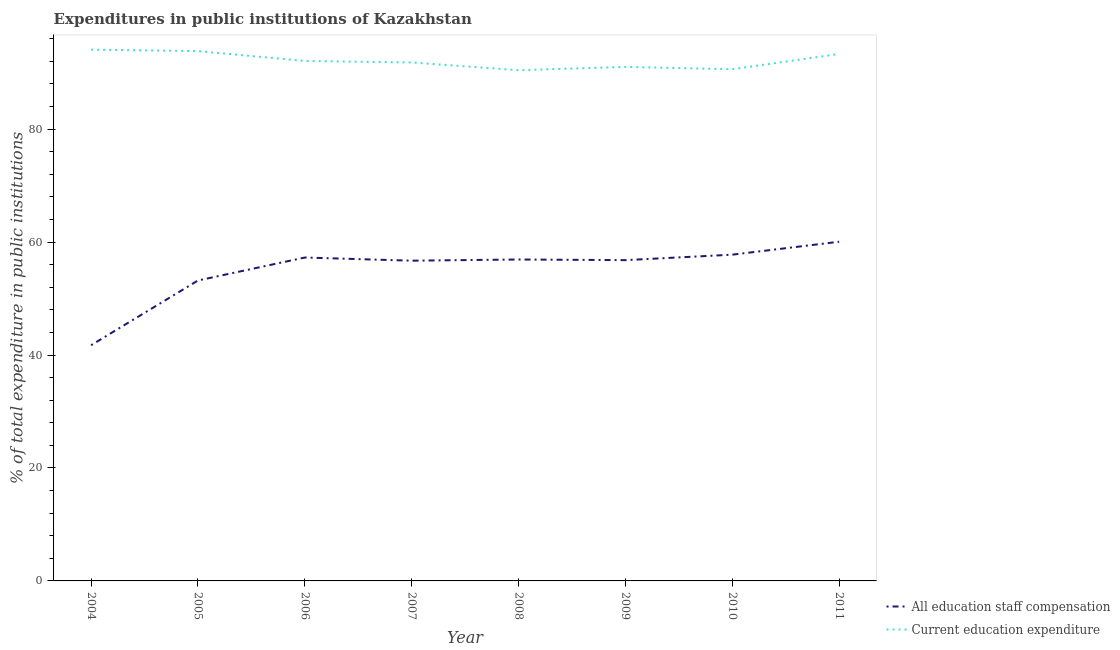Does the line corresponding to expenditure in staff compensation intersect with the line corresponding to expenditure in education?
Offer a terse response. No. What is the expenditure in staff compensation in 2004?
Your answer should be compact. 41.74. Across all years, what is the maximum expenditure in staff compensation?
Provide a short and direct response. 60.06. Across all years, what is the minimum expenditure in education?
Give a very brief answer. 90.43. In which year was the expenditure in education maximum?
Keep it short and to the point. 2004. What is the total expenditure in staff compensation in the graph?
Keep it short and to the point. 440.46. What is the difference between the expenditure in staff compensation in 2006 and that in 2010?
Your response must be concise. -0.5. What is the difference between the expenditure in education in 2004 and the expenditure in staff compensation in 2008?
Provide a succinct answer. 37.16. What is the average expenditure in staff compensation per year?
Make the answer very short. 55.06. In the year 2011, what is the difference between the expenditure in education and expenditure in staff compensation?
Provide a short and direct response. 33.25. In how many years, is the expenditure in staff compensation greater than 40 %?
Your response must be concise. 8. What is the ratio of the expenditure in staff compensation in 2005 to that in 2008?
Ensure brevity in your answer.  0.93. Is the difference between the expenditure in staff compensation in 2008 and 2011 greater than the difference between the expenditure in education in 2008 and 2011?
Offer a terse response. No. What is the difference between the highest and the second highest expenditure in education?
Provide a short and direct response. 0.26. What is the difference between the highest and the lowest expenditure in education?
Make the answer very short. 3.64. Is the sum of the expenditure in staff compensation in 2005 and 2006 greater than the maximum expenditure in education across all years?
Provide a succinct answer. Yes. Does the expenditure in staff compensation monotonically increase over the years?
Offer a very short reply. No. Is the expenditure in staff compensation strictly greater than the expenditure in education over the years?
Provide a succinct answer. No. Is the expenditure in education strictly less than the expenditure in staff compensation over the years?
Keep it short and to the point. No. How many lines are there?
Your response must be concise. 2. How many years are there in the graph?
Provide a short and direct response. 8. What is the difference between two consecutive major ticks on the Y-axis?
Your answer should be very brief. 20. Does the graph contain any zero values?
Your answer should be very brief. No. Where does the legend appear in the graph?
Give a very brief answer. Bottom right. How are the legend labels stacked?
Offer a terse response. Vertical. What is the title of the graph?
Provide a short and direct response. Expenditures in public institutions of Kazakhstan. What is the label or title of the Y-axis?
Make the answer very short. % of total expenditure in public institutions. What is the % of total expenditure in public institutions in All education staff compensation in 2004?
Your answer should be compact. 41.74. What is the % of total expenditure in public institutions in Current education expenditure in 2004?
Give a very brief answer. 94.07. What is the % of total expenditure in public institutions of All education staff compensation in 2005?
Your answer should be compact. 53.2. What is the % of total expenditure in public institutions in Current education expenditure in 2005?
Give a very brief answer. 93.81. What is the % of total expenditure in public institutions in All education staff compensation in 2006?
Offer a terse response. 57.27. What is the % of total expenditure in public institutions of Current education expenditure in 2006?
Ensure brevity in your answer.  92.07. What is the % of total expenditure in public institutions of All education staff compensation in 2007?
Ensure brevity in your answer.  56.71. What is the % of total expenditure in public institutions of Current education expenditure in 2007?
Your answer should be compact. 91.8. What is the % of total expenditure in public institutions in All education staff compensation in 2008?
Ensure brevity in your answer.  56.92. What is the % of total expenditure in public institutions of Current education expenditure in 2008?
Offer a terse response. 90.43. What is the % of total expenditure in public institutions in All education staff compensation in 2009?
Your answer should be very brief. 56.8. What is the % of total expenditure in public institutions of Current education expenditure in 2009?
Give a very brief answer. 91.02. What is the % of total expenditure in public institutions of All education staff compensation in 2010?
Your answer should be very brief. 57.77. What is the % of total expenditure in public institutions in Current education expenditure in 2010?
Offer a very short reply. 90.6. What is the % of total expenditure in public institutions of All education staff compensation in 2011?
Make the answer very short. 60.06. What is the % of total expenditure in public institutions in Current education expenditure in 2011?
Make the answer very short. 93.31. Across all years, what is the maximum % of total expenditure in public institutions in All education staff compensation?
Your response must be concise. 60.06. Across all years, what is the maximum % of total expenditure in public institutions of Current education expenditure?
Your response must be concise. 94.07. Across all years, what is the minimum % of total expenditure in public institutions in All education staff compensation?
Your response must be concise. 41.74. Across all years, what is the minimum % of total expenditure in public institutions of Current education expenditure?
Offer a terse response. 90.43. What is the total % of total expenditure in public institutions in All education staff compensation in the graph?
Your response must be concise. 440.46. What is the total % of total expenditure in public institutions of Current education expenditure in the graph?
Provide a short and direct response. 737.13. What is the difference between the % of total expenditure in public institutions of All education staff compensation in 2004 and that in 2005?
Your answer should be compact. -11.46. What is the difference between the % of total expenditure in public institutions in Current education expenditure in 2004 and that in 2005?
Provide a succinct answer. 0.26. What is the difference between the % of total expenditure in public institutions in All education staff compensation in 2004 and that in 2006?
Offer a very short reply. -15.53. What is the difference between the % of total expenditure in public institutions of Current education expenditure in 2004 and that in 2006?
Your response must be concise. 2. What is the difference between the % of total expenditure in public institutions in All education staff compensation in 2004 and that in 2007?
Provide a succinct answer. -14.97. What is the difference between the % of total expenditure in public institutions of Current education expenditure in 2004 and that in 2007?
Ensure brevity in your answer.  2.27. What is the difference between the % of total expenditure in public institutions in All education staff compensation in 2004 and that in 2008?
Give a very brief answer. -15.18. What is the difference between the % of total expenditure in public institutions in Current education expenditure in 2004 and that in 2008?
Ensure brevity in your answer.  3.64. What is the difference between the % of total expenditure in public institutions of All education staff compensation in 2004 and that in 2009?
Provide a succinct answer. -15.06. What is the difference between the % of total expenditure in public institutions of Current education expenditure in 2004 and that in 2009?
Your response must be concise. 3.05. What is the difference between the % of total expenditure in public institutions in All education staff compensation in 2004 and that in 2010?
Provide a short and direct response. -16.03. What is the difference between the % of total expenditure in public institutions of Current education expenditure in 2004 and that in 2010?
Make the answer very short. 3.47. What is the difference between the % of total expenditure in public institutions in All education staff compensation in 2004 and that in 2011?
Keep it short and to the point. -18.32. What is the difference between the % of total expenditure in public institutions in Current education expenditure in 2004 and that in 2011?
Offer a very short reply. 0.76. What is the difference between the % of total expenditure in public institutions of All education staff compensation in 2005 and that in 2006?
Offer a very short reply. -4.07. What is the difference between the % of total expenditure in public institutions of Current education expenditure in 2005 and that in 2006?
Keep it short and to the point. 1.74. What is the difference between the % of total expenditure in public institutions of All education staff compensation in 2005 and that in 2007?
Your answer should be very brief. -3.51. What is the difference between the % of total expenditure in public institutions in Current education expenditure in 2005 and that in 2007?
Your answer should be very brief. 2.01. What is the difference between the % of total expenditure in public institutions of All education staff compensation in 2005 and that in 2008?
Give a very brief answer. -3.72. What is the difference between the % of total expenditure in public institutions in Current education expenditure in 2005 and that in 2008?
Your answer should be very brief. 3.38. What is the difference between the % of total expenditure in public institutions in All education staff compensation in 2005 and that in 2009?
Your answer should be compact. -3.6. What is the difference between the % of total expenditure in public institutions of Current education expenditure in 2005 and that in 2009?
Provide a succinct answer. 2.79. What is the difference between the % of total expenditure in public institutions of All education staff compensation in 2005 and that in 2010?
Make the answer very short. -4.57. What is the difference between the % of total expenditure in public institutions in Current education expenditure in 2005 and that in 2010?
Make the answer very short. 3.21. What is the difference between the % of total expenditure in public institutions of All education staff compensation in 2005 and that in 2011?
Your answer should be compact. -6.86. What is the difference between the % of total expenditure in public institutions in Current education expenditure in 2005 and that in 2011?
Provide a succinct answer. 0.5. What is the difference between the % of total expenditure in public institutions of All education staff compensation in 2006 and that in 2007?
Give a very brief answer. 0.56. What is the difference between the % of total expenditure in public institutions in Current education expenditure in 2006 and that in 2007?
Make the answer very short. 0.27. What is the difference between the % of total expenditure in public institutions in All education staff compensation in 2006 and that in 2008?
Give a very brief answer. 0.35. What is the difference between the % of total expenditure in public institutions in Current education expenditure in 2006 and that in 2008?
Provide a succinct answer. 1.64. What is the difference between the % of total expenditure in public institutions in All education staff compensation in 2006 and that in 2009?
Keep it short and to the point. 0.46. What is the difference between the % of total expenditure in public institutions in Current education expenditure in 2006 and that in 2009?
Give a very brief answer. 1.05. What is the difference between the % of total expenditure in public institutions of All education staff compensation in 2006 and that in 2010?
Your answer should be compact. -0.5. What is the difference between the % of total expenditure in public institutions in Current education expenditure in 2006 and that in 2010?
Offer a terse response. 1.47. What is the difference between the % of total expenditure in public institutions of All education staff compensation in 2006 and that in 2011?
Give a very brief answer. -2.8. What is the difference between the % of total expenditure in public institutions of Current education expenditure in 2006 and that in 2011?
Your answer should be very brief. -1.24. What is the difference between the % of total expenditure in public institutions of All education staff compensation in 2007 and that in 2008?
Provide a succinct answer. -0.21. What is the difference between the % of total expenditure in public institutions in Current education expenditure in 2007 and that in 2008?
Offer a terse response. 1.37. What is the difference between the % of total expenditure in public institutions of All education staff compensation in 2007 and that in 2009?
Ensure brevity in your answer.  -0.1. What is the difference between the % of total expenditure in public institutions of Current education expenditure in 2007 and that in 2009?
Your answer should be compact. 0.78. What is the difference between the % of total expenditure in public institutions in All education staff compensation in 2007 and that in 2010?
Provide a short and direct response. -1.06. What is the difference between the % of total expenditure in public institutions in Current education expenditure in 2007 and that in 2010?
Your response must be concise. 1.2. What is the difference between the % of total expenditure in public institutions of All education staff compensation in 2007 and that in 2011?
Ensure brevity in your answer.  -3.36. What is the difference between the % of total expenditure in public institutions in Current education expenditure in 2007 and that in 2011?
Give a very brief answer. -1.51. What is the difference between the % of total expenditure in public institutions in All education staff compensation in 2008 and that in 2009?
Your answer should be compact. 0.11. What is the difference between the % of total expenditure in public institutions of Current education expenditure in 2008 and that in 2009?
Your answer should be very brief. -0.59. What is the difference between the % of total expenditure in public institutions of All education staff compensation in 2008 and that in 2010?
Make the answer very short. -0.85. What is the difference between the % of total expenditure in public institutions in Current education expenditure in 2008 and that in 2010?
Provide a short and direct response. -0.17. What is the difference between the % of total expenditure in public institutions in All education staff compensation in 2008 and that in 2011?
Your answer should be compact. -3.15. What is the difference between the % of total expenditure in public institutions of Current education expenditure in 2008 and that in 2011?
Provide a succinct answer. -2.88. What is the difference between the % of total expenditure in public institutions of All education staff compensation in 2009 and that in 2010?
Your response must be concise. -0.97. What is the difference between the % of total expenditure in public institutions of Current education expenditure in 2009 and that in 2010?
Make the answer very short. 0.42. What is the difference between the % of total expenditure in public institutions of All education staff compensation in 2009 and that in 2011?
Your answer should be compact. -3.26. What is the difference between the % of total expenditure in public institutions of Current education expenditure in 2009 and that in 2011?
Keep it short and to the point. -2.29. What is the difference between the % of total expenditure in public institutions in All education staff compensation in 2010 and that in 2011?
Give a very brief answer. -2.29. What is the difference between the % of total expenditure in public institutions in Current education expenditure in 2010 and that in 2011?
Provide a succinct answer. -2.71. What is the difference between the % of total expenditure in public institutions of All education staff compensation in 2004 and the % of total expenditure in public institutions of Current education expenditure in 2005?
Provide a short and direct response. -52.07. What is the difference between the % of total expenditure in public institutions of All education staff compensation in 2004 and the % of total expenditure in public institutions of Current education expenditure in 2006?
Offer a very short reply. -50.33. What is the difference between the % of total expenditure in public institutions in All education staff compensation in 2004 and the % of total expenditure in public institutions in Current education expenditure in 2007?
Provide a short and direct response. -50.06. What is the difference between the % of total expenditure in public institutions of All education staff compensation in 2004 and the % of total expenditure in public institutions of Current education expenditure in 2008?
Make the answer very short. -48.69. What is the difference between the % of total expenditure in public institutions of All education staff compensation in 2004 and the % of total expenditure in public institutions of Current education expenditure in 2009?
Your answer should be compact. -49.28. What is the difference between the % of total expenditure in public institutions in All education staff compensation in 2004 and the % of total expenditure in public institutions in Current education expenditure in 2010?
Provide a short and direct response. -48.87. What is the difference between the % of total expenditure in public institutions of All education staff compensation in 2004 and the % of total expenditure in public institutions of Current education expenditure in 2011?
Give a very brief answer. -51.57. What is the difference between the % of total expenditure in public institutions in All education staff compensation in 2005 and the % of total expenditure in public institutions in Current education expenditure in 2006?
Make the answer very short. -38.87. What is the difference between the % of total expenditure in public institutions of All education staff compensation in 2005 and the % of total expenditure in public institutions of Current education expenditure in 2007?
Your answer should be very brief. -38.6. What is the difference between the % of total expenditure in public institutions of All education staff compensation in 2005 and the % of total expenditure in public institutions of Current education expenditure in 2008?
Provide a succinct answer. -37.23. What is the difference between the % of total expenditure in public institutions of All education staff compensation in 2005 and the % of total expenditure in public institutions of Current education expenditure in 2009?
Give a very brief answer. -37.82. What is the difference between the % of total expenditure in public institutions of All education staff compensation in 2005 and the % of total expenditure in public institutions of Current education expenditure in 2010?
Your response must be concise. -37.41. What is the difference between the % of total expenditure in public institutions in All education staff compensation in 2005 and the % of total expenditure in public institutions in Current education expenditure in 2011?
Provide a succinct answer. -40.11. What is the difference between the % of total expenditure in public institutions in All education staff compensation in 2006 and the % of total expenditure in public institutions in Current education expenditure in 2007?
Your answer should be very brief. -34.54. What is the difference between the % of total expenditure in public institutions of All education staff compensation in 2006 and the % of total expenditure in public institutions of Current education expenditure in 2008?
Provide a succinct answer. -33.17. What is the difference between the % of total expenditure in public institutions in All education staff compensation in 2006 and the % of total expenditure in public institutions in Current education expenditure in 2009?
Provide a short and direct response. -33.76. What is the difference between the % of total expenditure in public institutions of All education staff compensation in 2006 and the % of total expenditure in public institutions of Current education expenditure in 2010?
Your response must be concise. -33.34. What is the difference between the % of total expenditure in public institutions of All education staff compensation in 2006 and the % of total expenditure in public institutions of Current education expenditure in 2011?
Keep it short and to the point. -36.05. What is the difference between the % of total expenditure in public institutions in All education staff compensation in 2007 and the % of total expenditure in public institutions in Current education expenditure in 2008?
Provide a short and direct response. -33.73. What is the difference between the % of total expenditure in public institutions in All education staff compensation in 2007 and the % of total expenditure in public institutions in Current education expenditure in 2009?
Your answer should be compact. -34.31. What is the difference between the % of total expenditure in public institutions of All education staff compensation in 2007 and the % of total expenditure in public institutions of Current education expenditure in 2010?
Give a very brief answer. -33.9. What is the difference between the % of total expenditure in public institutions in All education staff compensation in 2007 and the % of total expenditure in public institutions in Current education expenditure in 2011?
Your answer should be very brief. -36.61. What is the difference between the % of total expenditure in public institutions of All education staff compensation in 2008 and the % of total expenditure in public institutions of Current education expenditure in 2009?
Offer a very short reply. -34.1. What is the difference between the % of total expenditure in public institutions in All education staff compensation in 2008 and the % of total expenditure in public institutions in Current education expenditure in 2010?
Provide a succinct answer. -33.69. What is the difference between the % of total expenditure in public institutions of All education staff compensation in 2008 and the % of total expenditure in public institutions of Current education expenditure in 2011?
Offer a terse response. -36.4. What is the difference between the % of total expenditure in public institutions of All education staff compensation in 2009 and the % of total expenditure in public institutions of Current education expenditure in 2010?
Provide a succinct answer. -33.8. What is the difference between the % of total expenditure in public institutions of All education staff compensation in 2009 and the % of total expenditure in public institutions of Current education expenditure in 2011?
Your response must be concise. -36.51. What is the difference between the % of total expenditure in public institutions in All education staff compensation in 2010 and the % of total expenditure in public institutions in Current education expenditure in 2011?
Make the answer very short. -35.54. What is the average % of total expenditure in public institutions of All education staff compensation per year?
Your answer should be very brief. 55.06. What is the average % of total expenditure in public institutions of Current education expenditure per year?
Make the answer very short. 92.14. In the year 2004, what is the difference between the % of total expenditure in public institutions of All education staff compensation and % of total expenditure in public institutions of Current education expenditure?
Give a very brief answer. -52.33. In the year 2005, what is the difference between the % of total expenditure in public institutions in All education staff compensation and % of total expenditure in public institutions in Current education expenditure?
Your answer should be compact. -40.61. In the year 2006, what is the difference between the % of total expenditure in public institutions of All education staff compensation and % of total expenditure in public institutions of Current education expenditure?
Keep it short and to the point. -34.81. In the year 2007, what is the difference between the % of total expenditure in public institutions in All education staff compensation and % of total expenditure in public institutions in Current education expenditure?
Provide a short and direct response. -35.1. In the year 2008, what is the difference between the % of total expenditure in public institutions in All education staff compensation and % of total expenditure in public institutions in Current education expenditure?
Keep it short and to the point. -33.52. In the year 2009, what is the difference between the % of total expenditure in public institutions of All education staff compensation and % of total expenditure in public institutions of Current education expenditure?
Your answer should be very brief. -34.22. In the year 2010, what is the difference between the % of total expenditure in public institutions in All education staff compensation and % of total expenditure in public institutions in Current education expenditure?
Ensure brevity in your answer.  -32.84. In the year 2011, what is the difference between the % of total expenditure in public institutions in All education staff compensation and % of total expenditure in public institutions in Current education expenditure?
Offer a very short reply. -33.25. What is the ratio of the % of total expenditure in public institutions in All education staff compensation in 2004 to that in 2005?
Offer a terse response. 0.78. What is the ratio of the % of total expenditure in public institutions of Current education expenditure in 2004 to that in 2005?
Keep it short and to the point. 1. What is the ratio of the % of total expenditure in public institutions of All education staff compensation in 2004 to that in 2006?
Provide a short and direct response. 0.73. What is the ratio of the % of total expenditure in public institutions in Current education expenditure in 2004 to that in 2006?
Offer a terse response. 1.02. What is the ratio of the % of total expenditure in public institutions of All education staff compensation in 2004 to that in 2007?
Provide a succinct answer. 0.74. What is the ratio of the % of total expenditure in public institutions of Current education expenditure in 2004 to that in 2007?
Give a very brief answer. 1.02. What is the ratio of the % of total expenditure in public institutions of All education staff compensation in 2004 to that in 2008?
Ensure brevity in your answer.  0.73. What is the ratio of the % of total expenditure in public institutions of Current education expenditure in 2004 to that in 2008?
Give a very brief answer. 1.04. What is the ratio of the % of total expenditure in public institutions in All education staff compensation in 2004 to that in 2009?
Keep it short and to the point. 0.73. What is the ratio of the % of total expenditure in public institutions of Current education expenditure in 2004 to that in 2009?
Keep it short and to the point. 1.03. What is the ratio of the % of total expenditure in public institutions in All education staff compensation in 2004 to that in 2010?
Give a very brief answer. 0.72. What is the ratio of the % of total expenditure in public institutions of Current education expenditure in 2004 to that in 2010?
Make the answer very short. 1.04. What is the ratio of the % of total expenditure in public institutions in All education staff compensation in 2004 to that in 2011?
Provide a succinct answer. 0.69. What is the ratio of the % of total expenditure in public institutions of Current education expenditure in 2004 to that in 2011?
Offer a terse response. 1.01. What is the ratio of the % of total expenditure in public institutions in All education staff compensation in 2005 to that in 2006?
Your answer should be very brief. 0.93. What is the ratio of the % of total expenditure in public institutions of Current education expenditure in 2005 to that in 2006?
Keep it short and to the point. 1.02. What is the ratio of the % of total expenditure in public institutions of All education staff compensation in 2005 to that in 2007?
Offer a terse response. 0.94. What is the ratio of the % of total expenditure in public institutions in Current education expenditure in 2005 to that in 2007?
Your answer should be compact. 1.02. What is the ratio of the % of total expenditure in public institutions of All education staff compensation in 2005 to that in 2008?
Offer a terse response. 0.93. What is the ratio of the % of total expenditure in public institutions of Current education expenditure in 2005 to that in 2008?
Provide a short and direct response. 1.04. What is the ratio of the % of total expenditure in public institutions in All education staff compensation in 2005 to that in 2009?
Your response must be concise. 0.94. What is the ratio of the % of total expenditure in public institutions of Current education expenditure in 2005 to that in 2009?
Your answer should be compact. 1.03. What is the ratio of the % of total expenditure in public institutions of All education staff compensation in 2005 to that in 2010?
Make the answer very short. 0.92. What is the ratio of the % of total expenditure in public institutions in Current education expenditure in 2005 to that in 2010?
Give a very brief answer. 1.04. What is the ratio of the % of total expenditure in public institutions of All education staff compensation in 2005 to that in 2011?
Give a very brief answer. 0.89. What is the ratio of the % of total expenditure in public institutions in Current education expenditure in 2005 to that in 2011?
Ensure brevity in your answer.  1.01. What is the ratio of the % of total expenditure in public institutions in All education staff compensation in 2006 to that in 2007?
Your answer should be compact. 1.01. What is the ratio of the % of total expenditure in public institutions of Current education expenditure in 2006 to that in 2007?
Ensure brevity in your answer.  1. What is the ratio of the % of total expenditure in public institutions in Current education expenditure in 2006 to that in 2008?
Your answer should be very brief. 1.02. What is the ratio of the % of total expenditure in public institutions in All education staff compensation in 2006 to that in 2009?
Make the answer very short. 1.01. What is the ratio of the % of total expenditure in public institutions in Current education expenditure in 2006 to that in 2009?
Your answer should be compact. 1.01. What is the ratio of the % of total expenditure in public institutions of All education staff compensation in 2006 to that in 2010?
Give a very brief answer. 0.99. What is the ratio of the % of total expenditure in public institutions of Current education expenditure in 2006 to that in 2010?
Make the answer very short. 1.02. What is the ratio of the % of total expenditure in public institutions in All education staff compensation in 2006 to that in 2011?
Give a very brief answer. 0.95. What is the ratio of the % of total expenditure in public institutions in Current education expenditure in 2006 to that in 2011?
Make the answer very short. 0.99. What is the ratio of the % of total expenditure in public institutions of All education staff compensation in 2007 to that in 2008?
Provide a succinct answer. 1. What is the ratio of the % of total expenditure in public institutions in Current education expenditure in 2007 to that in 2008?
Your answer should be very brief. 1.02. What is the ratio of the % of total expenditure in public institutions in Current education expenditure in 2007 to that in 2009?
Your answer should be compact. 1.01. What is the ratio of the % of total expenditure in public institutions in All education staff compensation in 2007 to that in 2010?
Your answer should be compact. 0.98. What is the ratio of the % of total expenditure in public institutions of Current education expenditure in 2007 to that in 2010?
Provide a short and direct response. 1.01. What is the ratio of the % of total expenditure in public institutions of All education staff compensation in 2007 to that in 2011?
Your answer should be very brief. 0.94. What is the ratio of the % of total expenditure in public institutions in Current education expenditure in 2007 to that in 2011?
Give a very brief answer. 0.98. What is the ratio of the % of total expenditure in public institutions in All education staff compensation in 2008 to that in 2009?
Your answer should be very brief. 1. What is the ratio of the % of total expenditure in public institutions in Current education expenditure in 2008 to that in 2009?
Your answer should be very brief. 0.99. What is the ratio of the % of total expenditure in public institutions in All education staff compensation in 2008 to that in 2010?
Give a very brief answer. 0.99. What is the ratio of the % of total expenditure in public institutions in Current education expenditure in 2008 to that in 2010?
Make the answer very short. 1. What is the ratio of the % of total expenditure in public institutions in All education staff compensation in 2008 to that in 2011?
Offer a very short reply. 0.95. What is the ratio of the % of total expenditure in public institutions in Current education expenditure in 2008 to that in 2011?
Your response must be concise. 0.97. What is the ratio of the % of total expenditure in public institutions of All education staff compensation in 2009 to that in 2010?
Offer a very short reply. 0.98. What is the ratio of the % of total expenditure in public institutions in All education staff compensation in 2009 to that in 2011?
Make the answer very short. 0.95. What is the ratio of the % of total expenditure in public institutions in Current education expenditure in 2009 to that in 2011?
Offer a very short reply. 0.98. What is the ratio of the % of total expenditure in public institutions in All education staff compensation in 2010 to that in 2011?
Provide a short and direct response. 0.96. What is the difference between the highest and the second highest % of total expenditure in public institutions in All education staff compensation?
Provide a succinct answer. 2.29. What is the difference between the highest and the second highest % of total expenditure in public institutions of Current education expenditure?
Your answer should be very brief. 0.26. What is the difference between the highest and the lowest % of total expenditure in public institutions of All education staff compensation?
Offer a very short reply. 18.32. What is the difference between the highest and the lowest % of total expenditure in public institutions of Current education expenditure?
Your response must be concise. 3.64. 